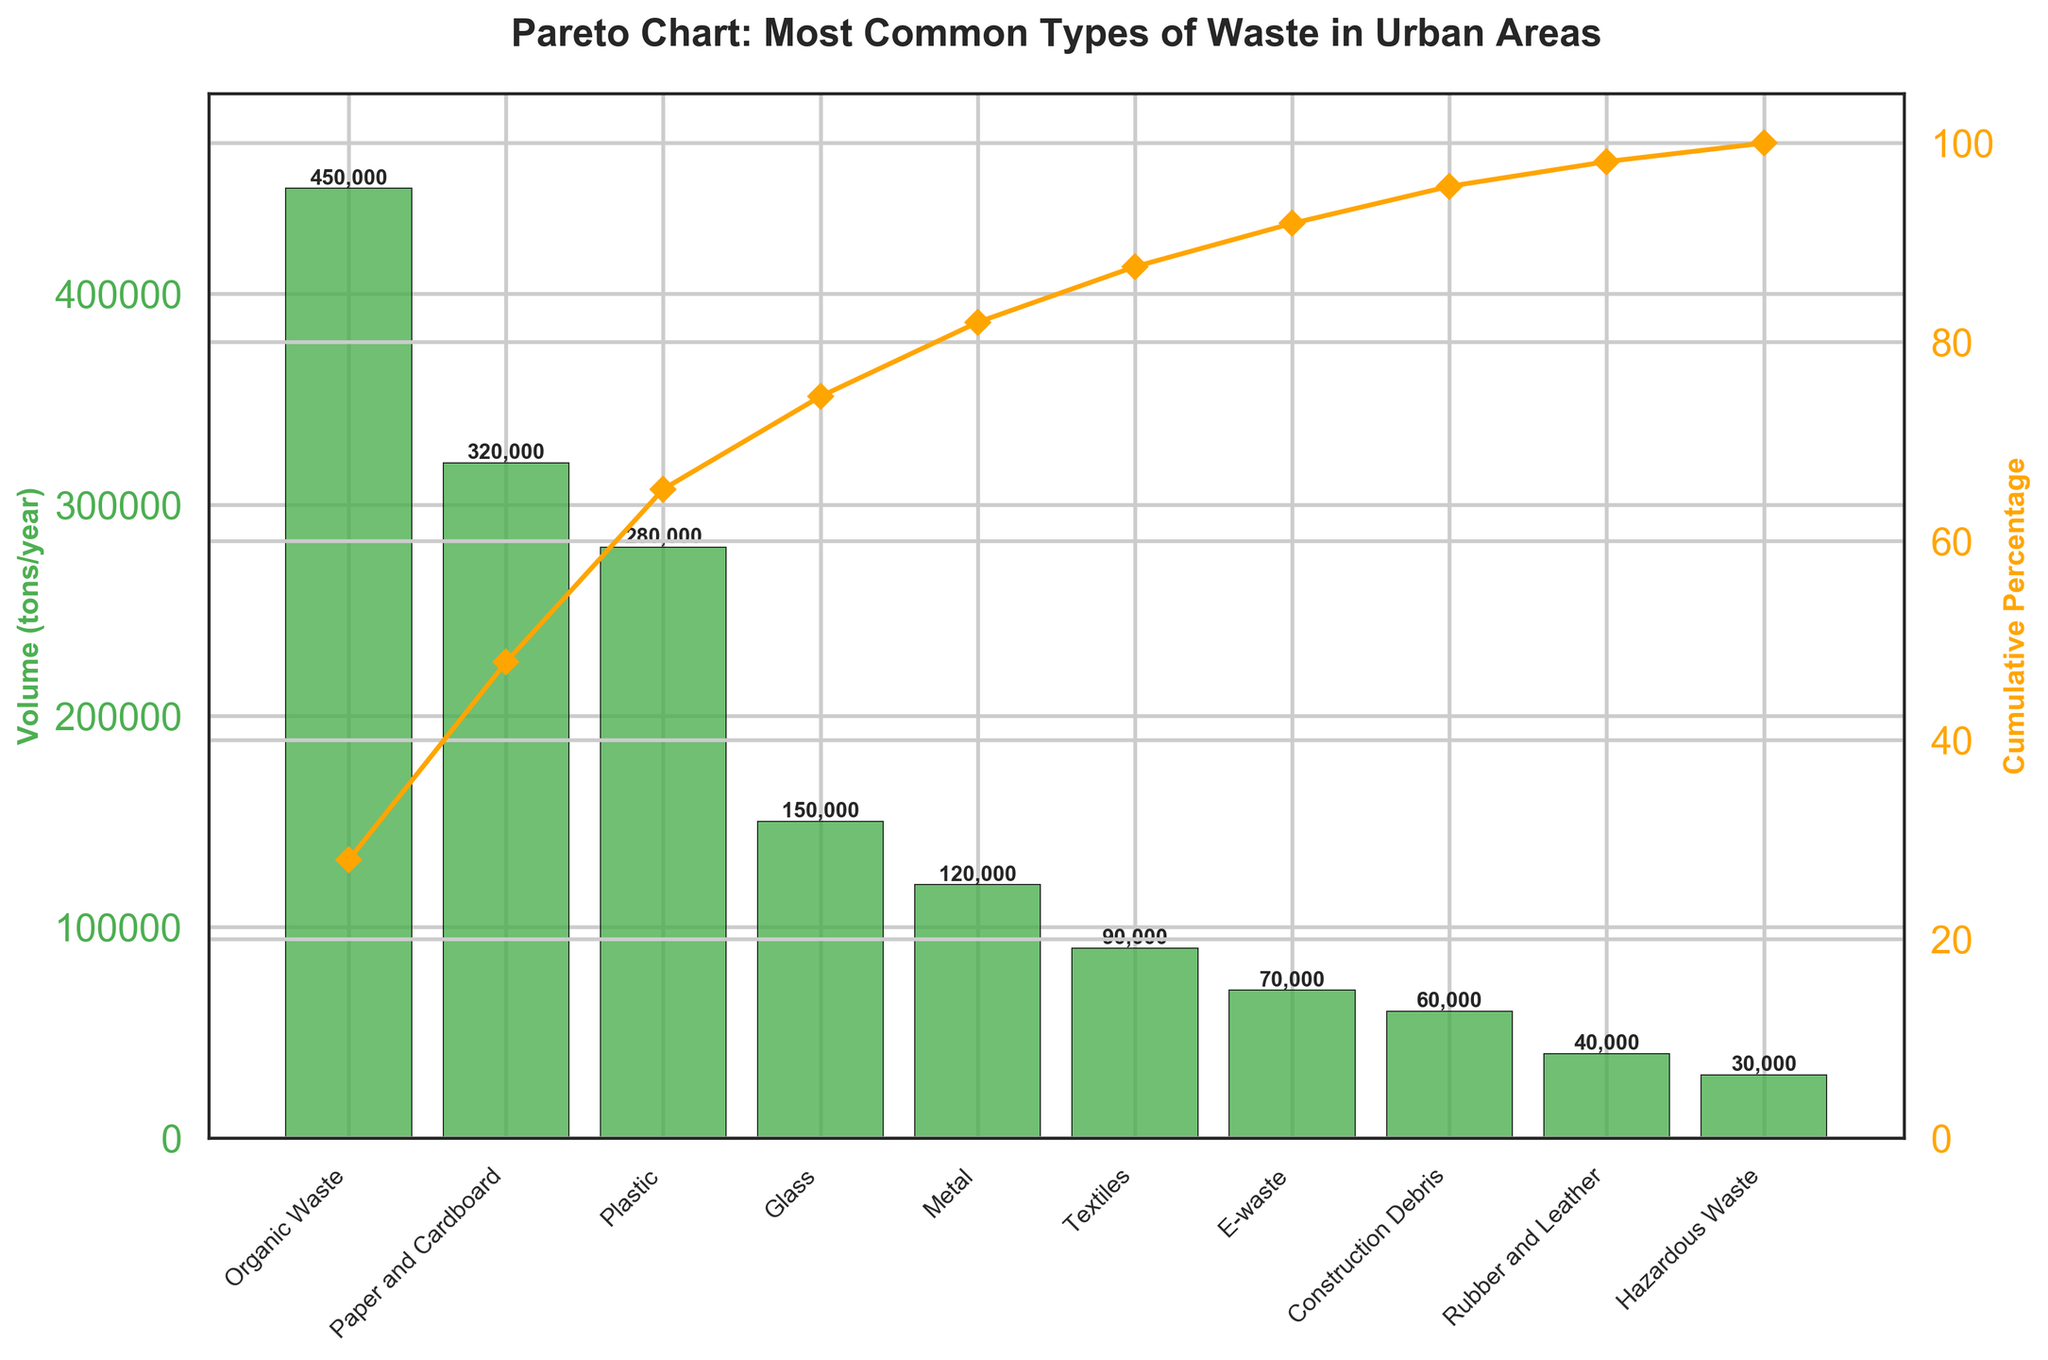What is the waste type that has the highest volume in urban areas? By looking at the highest bar in the Pareto chart, you can see that "Organic Waste" has the highest volume.
Answer: Organic Waste How many waste types have a volume greater than 100,000 tons per year? By counting the bars that extend above the 100,000 tons/year mark on the y-axis, you can see there are five: Organic Waste, Paper and Cardboard, Plastic, Glass, and Metal.
Answer: 5 What is the cumulative percentage of waste accounted for by the top three waste types? The cumulative percentage line helps with this. Look at the point above the third bar (Plastic), which shows approximately 72%.
Answer: 72% Which waste type ranks fifth in volume? By following the fifth tallest bar from largest to smallest, you find that "Metal" is the fifth in volume.
Answer: Metal What is the combined volume of Paper and Cardboard, and Plastic? Adding the volumes of Paper and Cardboard (320,000 tons/year) and Plastic (280,000 tons/year) gives 600,000 tons/year.
Answer: 600,000 Which waste type contributes just below 50% to the cumulative waste volume? By checking the cumulative percentage line and locating the point just below 50%, you find it aligns with "Plastic".
Answer: Plastic How does the volume of Glass compare to Metal? Comparing the heights of the bars for Glass (150,000 tons/year) and Metal (120,000 tons/year), Glass has a higher volume.
Answer: Glass has a higher volume What volume range do the least common 3 types of waste fall into? By observing the three smallest bars: Rubber and Leather (40,000 tons/year), and Hazardous Waste (30,000 tons/year), you can see they all fall into the 30,000-40,000 tons/year range.
Answer: 30,000-40,000 tons/year By what percentage does Organic Waste exceed Paper and Cardboard in volume? Organic Waste is 450,000 tons/year, and Paper and Cardboard is 320,000 tons/year. The difference is 130,000 tons/year. Divide by Paper and Cardboard's volume and multiply by 100 to get about 40.6%.
Answer: 40.6% What waste types together constitute approximately the first 80% of the cumulative waste volume? By tracking the cumulative percentage line, you can see that Organic Waste, Paper and Cardboard, Plastic, and Glass together make approximately the first 80%.
Answer: Organic Waste, Paper and Cardboard, Plastic, Glass 